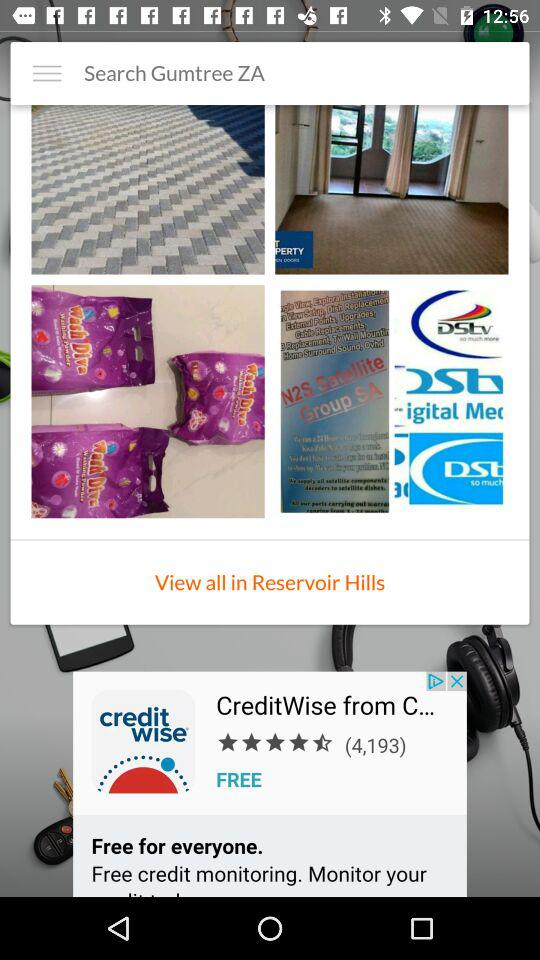What is the application name? The application name is "Gumtree Poland". 